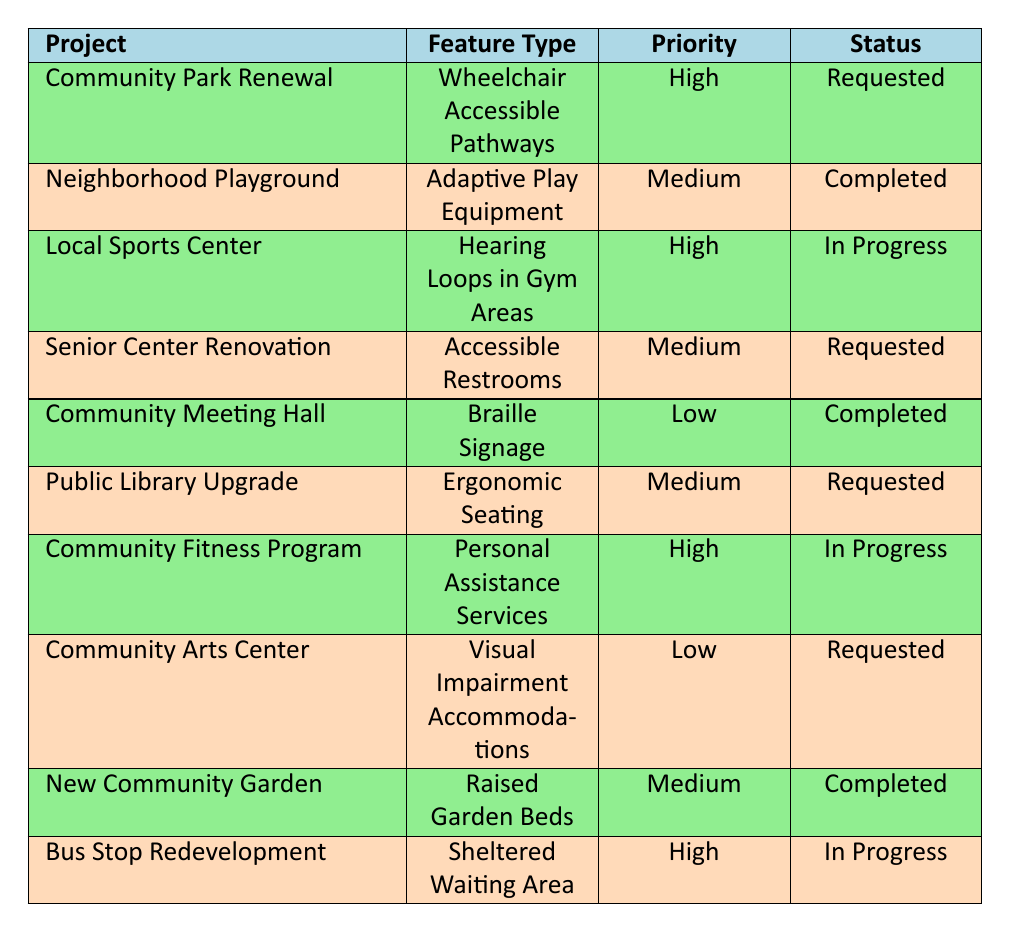What accessibility feature has the highest priority that is currently requested? By looking at the table, the highest priority feature that has the status "Requested" is "Wheelchair Accessible Pathways" for the "Community Park Renewal" project.
Answer: Wheelchair Accessible Pathways How many features are marked as completed? There are three features in the table that have the status "Completed": "Adaptive Play Equipment", "Braille Signage", and "Raised Garden Beds".
Answer: 3 Is there any feature related to "Personal Assistance Services"? Yes, there is a feature labeled "Personal Assistance Services" which is in the "Community Fitness Program" and has a high priority and is in progress.
Answer: Yes Which project has requested ergonomic seating? The "Public Library Upgrade" project has requested "Ergonomic Seating" and its priority level is medium.
Answer: Public Library Upgrade What is the total number of features currently in progress? There are three features marked "In Progress": "Hearing Loops in Gym Areas", "Personal Assistance Services", and "Sheltered Waiting Area". Hence, the total is three.
Answer: 3 Are there more features requested than completed? Yes, looking at the table, there are 4 features marked as 'Requested' and 3 features marked as 'Completed', thus there are more requested features.
Answer: Yes What is the priority distribution of features that are completed? Upon analyzing the completed features, there is one high priority (none), one medium priority ("Adaptive Play Equipment"), and one low priority ("Braille Signage"). Thus, the distribution is: 0 high, 1 medium, and 1 low.
Answer: 0 high, 1 medium, 1 low Which residence requested a feature for the community arts center? "Laura Martinez" from "Seaside Villas" has requested "Visual Impairment Accommodations" for the "Community Arts Center".
Answer: Seaside Villas How many unique residences are represented in the requests shown? There are 7 unique residences that made requests: Maplewood Apartments, Greenfield Homes, Sunrise Villas, Oakridge Community, Riverbend Estates, Cedar Grove, and Hillcrest Homes, totaling 7.
Answer: 7 What feature type was requested by more than one resident? No feature type appears to be requested by more than one resident; each feature request is unique to a specific resident.
Answer: No 